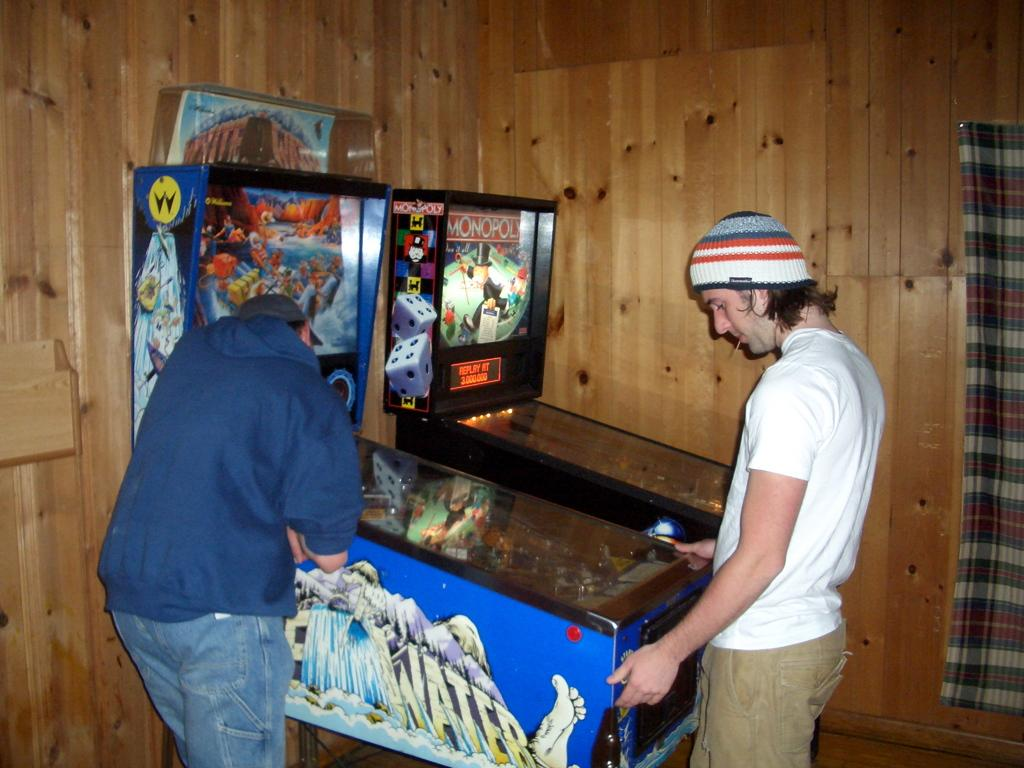How many people are in the image? There are two people in the image. What are the people standing near in the image? The people are standing near slot machines in the image. What type of material is used for the curtain in the image? The curtain in the image is not described in terms of material, so we cannot determine if it is made of wood or any other material. What type of wall can be seen in the image? There is a wooden wall visible in the image. What type of sand can be seen on the floor in the image? There is no sand present on the floor in the image; it features a wooden wall and people standing near slot machines. 